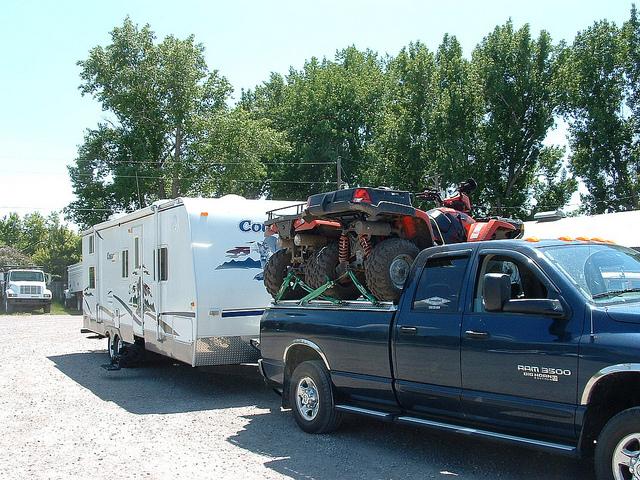What make is the truck?
Be succinct. Dodge. What's being towed?
Be succinct. Camper. What color is the truck?
Quick response, please. Black. 